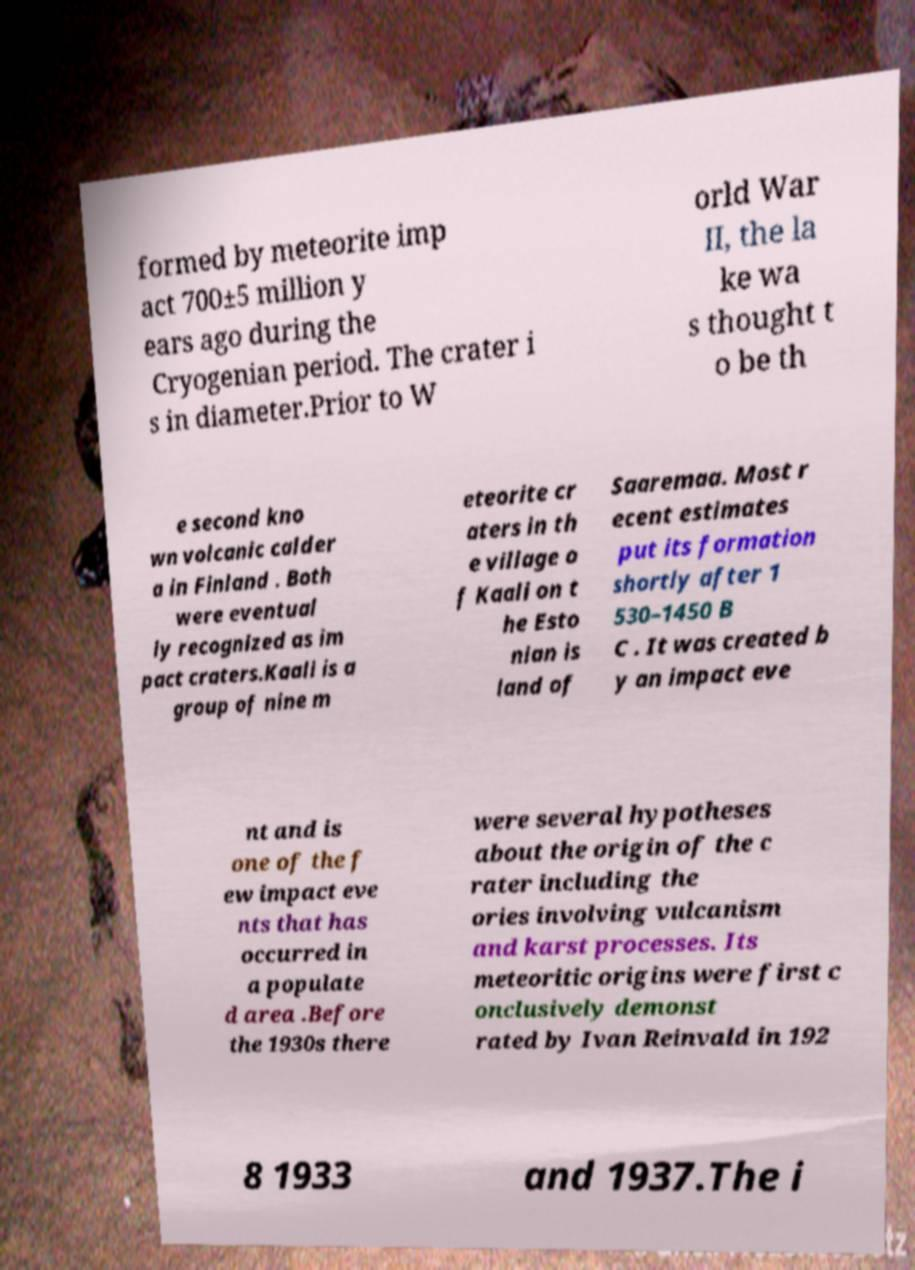Please identify and transcribe the text found in this image. formed by meteorite imp act 700±5 million y ears ago during the Cryogenian period. The crater i s in diameter.Prior to W orld War II, the la ke wa s thought t o be th e second kno wn volcanic calder a in Finland . Both were eventual ly recognized as im pact craters.Kaali is a group of nine m eteorite cr aters in th e village o f Kaali on t he Esto nian is land of Saaremaa. Most r ecent estimates put its formation shortly after 1 530–1450 B C . It was created b y an impact eve nt and is one of the f ew impact eve nts that has occurred in a populate d area .Before the 1930s there were several hypotheses about the origin of the c rater including the ories involving vulcanism and karst processes. Its meteoritic origins were first c onclusively demonst rated by Ivan Reinvald in 192 8 1933 and 1937.The i 